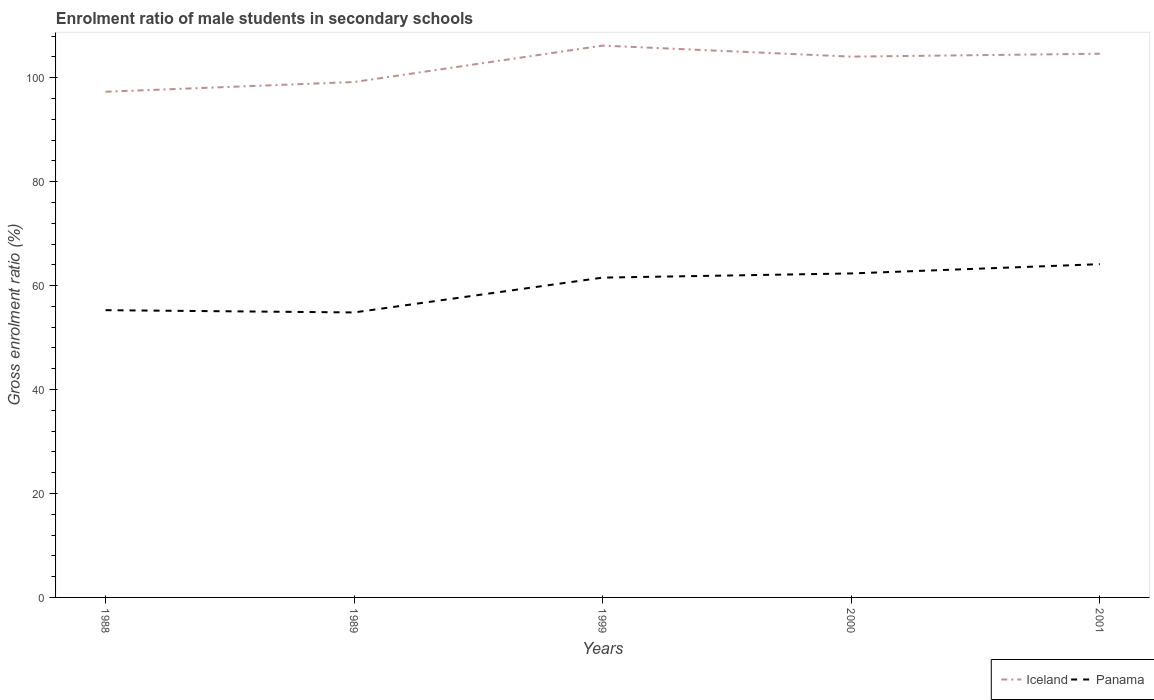Does the line corresponding to Iceland intersect with the line corresponding to Panama?
Ensure brevity in your answer.  No. Across all years, what is the maximum enrolment ratio of male students in secondary schools in Panama?
Your response must be concise. 54.83. In which year was the enrolment ratio of male students in secondary schools in Panama maximum?
Your answer should be very brief. 1989. What is the total enrolment ratio of male students in secondary schools in Iceland in the graph?
Provide a succinct answer. 2.12. What is the difference between the highest and the second highest enrolment ratio of male students in secondary schools in Iceland?
Offer a terse response. 8.88. Is the enrolment ratio of male students in secondary schools in Iceland strictly greater than the enrolment ratio of male students in secondary schools in Panama over the years?
Make the answer very short. No. How many years are there in the graph?
Keep it short and to the point. 5. Does the graph contain any zero values?
Your response must be concise. No. What is the title of the graph?
Offer a terse response. Enrolment ratio of male students in secondary schools. Does "Caribbean small states" appear as one of the legend labels in the graph?
Give a very brief answer. No. What is the label or title of the X-axis?
Keep it short and to the point. Years. What is the Gross enrolment ratio (%) in Iceland in 1988?
Make the answer very short. 97.3. What is the Gross enrolment ratio (%) of Panama in 1988?
Keep it short and to the point. 55.27. What is the Gross enrolment ratio (%) in Iceland in 1989?
Your answer should be compact. 99.17. What is the Gross enrolment ratio (%) of Panama in 1989?
Your answer should be compact. 54.83. What is the Gross enrolment ratio (%) of Iceland in 1999?
Provide a succinct answer. 106.18. What is the Gross enrolment ratio (%) of Panama in 1999?
Provide a succinct answer. 61.54. What is the Gross enrolment ratio (%) in Iceland in 2000?
Your response must be concise. 104.06. What is the Gross enrolment ratio (%) in Panama in 2000?
Ensure brevity in your answer.  62.34. What is the Gross enrolment ratio (%) of Iceland in 2001?
Ensure brevity in your answer.  104.61. What is the Gross enrolment ratio (%) in Panama in 2001?
Give a very brief answer. 64.13. Across all years, what is the maximum Gross enrolment ratio (%) of Iceland?
Keep it short and to the point. 106.18. Across all years, what is the maximum Gross enrolment ratio (%) of Panama?
Your answer should be very brief. 64.13. Across all years, what is the minimum Gross enrolment ratio (%) in Iceland?
Ensure brevity in your answer.  97.3. Across all years, what is the minimum Gross enrolment ratio (%) of Panama?
Provide a short and direct response. 54.83. What is the total Gross enrolment ratio (%) in Iceland in the graph?
Offer a terse response. 511.32. What is the total Gross enrolment ratio (%) in Panama in the graph?
Give a very brief answer. 298.11. What is the difference between the Gross enrolment ratio (%) in Iceland in 1988 and that in 1989?
Give a very brief answer. -1.87. What is the difference between the Gross enrolment ratio (%) in Panama in 1988 and that in 1989?
Your answer should be very brief. 0.44. What is the difference between the Gross enrolment ratio (%) of Iceland in 1988 and that in 1999?
Ensure brevity in your answer.  -8.88. What is the difference between the Gross enrolment ratio (%) in Panama in 1988 and that in 1999?
Your response must be concise. -6.26. What is the difference between the Gross enrolment ratio (%) of Iceland in 1988 and that in 2000?
Your response must be concise. -6.76. What is the difference between the Gross enrolment ratio (%) in Panama in 1988 and that in 2000?
Your response must be concise. -7.07. What is the difference between the Gross enrolment ratio (%) in Iceland in 1988 and that in 2001?
Provide a succinct answer. -7.31. What is the difference between the Gross enrolment ratio (%) in Panama in 1988 and that in 2001?
Provide a succinct answer. -8.85. What is the difference between the Gross enrolment ratio (%) of Iceland in 1989 and that in 1999?
Give a very brief answer. -7.01. What is the difference between the Gross enrolment ratio (%) of Panama in 1989 and that in 1999?
Provide a succinct answer. -6.7. What is the difference between the Gross enrolment ratio (%) in Iceland in 1989 and that in 2000?
Provide a short and direct response. -4.88. What is the difference between the Gross enrolment ratio (%) of Panama in 1989 and that in 2000?
Keep it short and to the point. -7.5. What is the difference between the Gross enrolment ratio (%) of Iceland in 1989 and that in 2001?
Ensure brevity in your answer.  -5.44. What is the difference between the Gross enrolment ratio (%) in Panama in 1989 and that in 2001?
Offer a terse response. -9.29. What is the difference between the Gross enrolment ratio (%) in Iceland in 1999 and that in 2000?
Offer a terse response. 2.12. What is the difference between the Gross enrolment ratio (%) of Panama in 1999 and that in 2000?
Your response must be concise. -0.8. What is the difference between the Gross enrolment ratio (%) of Iceland in 1999 and that in 2001?
Your answer should be compact. 1.57. What is the difference between the Gross enrolment ratio (%) of Panama in 1999 and that in 2001?
Provide a succinct answer. -2.59. What is the difference between the Gross enrolment ratio (%) of Iceland in 2000 and that in 2001?
Your response must be concise. -0.56. What is the difference between the Gross enrolment ratio (%) of Panama in 2000 and that in 2001?
Make the answer very short. -1.79. What is the difference between the Gross enrolment ratio (%) of Iceland in 1988 and the Gross enrolment ratio (%) of Panama in 1989?
Ensure brevity in your answer.  42.47. What is the difference between the Gross enrolment ratio (%) of Iceland in 1988 and the Gross enrolment ratio (%) of Panama in 1999?
Make the answer very short. 35.76. What is the difference between the Gross enrolment ratio (%) in Iceland in 1988 and the Gross enrolment ratio (%) in Panama in 2000?
Offer a very short reply. 34.96. What is the difference between the Gross enrolment ratio (%) in Iceland in 1988 and the Gross enrolment ratio (%) in Panama in 2001?
Your answer should be very brief. 33.17. What is the difference between the Gross enrolment ratio (%) of Iceland in 1989 and the Gross enrolment ratio (%) of Panama in 1999?
Provide a succinct answer. 37.64. What is the difference between the Gross enrolment ratio (%) of Iceland in 1989 and the Gross enrolment ratio (%) of Panama in 2000?
Make the answer very short. 36.83. What is the difference between the Gross enrolment ratio (%) of Iceland in 1989 and the Gross enrolment ratio (%) of Panama in 2001?
Your answer should be very brief. 35.05. What is the difference between the Gross enrolment ratio (%) in Iceland in 1999 and the Gross enrolment ratio (%) in Panama in 2000?
Provide a succinct answer. 43.84. What is the difference between the Gross enrolment ratio (%) of Iceland in 1999 and the Gross enrolment ratio (%) of Panama in 2001?
Keep it short and to the point. 42.05. What is the difference between the Gross enrolment ratio (%) in Iceland in 2000 and the Gross enrolment ratio (%) in Panama in 2001?
Give a very brief answer. 39.93. What is the average Gross enrolment ratio (%) of Iceland per year?
Provide a short and direct response. 102.26. What is the average Gross enrolment ratio (%) of Panama per year?
Offer a very short reply. 59.62. In the year 1988, what is the difference between the Gross enrolment ratio (%) of Iceland and Gross enrolment ratio (%) of Panama?
Offer a very short reply. 42.03. In the year 1989, what is the difference between the Gross enrolment ratio (%) of Iceland and Gross enrolment ratio (%) of Panama?
Your response must be concise. 44.34. In the year 1999, what is the difference between the Gross enrolment ratio (%) of Iceland and Gross enrolment ratio (%) of Panama?
Your answer should be very brief. 44.64. In the year 2000, what is the difference between the Gross enrolment ratio (%) of Iceland and Gross enrolment ratio (%) of Panama?
Keep it short and to the point. 41.72. In the year 2001, what is the difference between the Gross enrolment ratio (%) of Iceland and Gross enrolment ratio (%) of Panama?
Provide a succinct answer. 40.49. What is the ratio of the Gross enrolment ratio (%) of Iceland in 1988 to that in 1989?
Your answer should be compact. 0.98. What is the ratio of the Gross enrolment ratio (%) in Iceland in 1988 to that in 1999?
Your response must be concise. 0.92. What is the ratio of the Gross enrolment ratio (%) in Panama in 1988 to that in 1999?
Make the answer very short. 0.9. What is the ratio of the Gross enrolment ratio (%) of Iceland in 1988 to that in 2000?
Your answer should be compact. 0.94. What is the ratio of the Gross enrolment ratio (%) of Panama in 1988 to that in 2000?
Give a very brief answer. 0.89. What is the ratio of the Gross enrolment ratio (%) in Iceland in 1988 to that in 2001?
Make the answer very short. 0.93. What is the ratio of the Gross enrolment ratio (%) of Panama in 1988 to that in 2001?
Make the answer very short. 0.86. What is the ratio of the Gross enrolment ratio (%) of Iceland in 1989 to that in 1999?
Ensure brevity in your answer.  0.93. What is the ratio of the Gross enrolment ratio (%) in Panama in 1989 to that in 1999?
Ensure brevity in your answer.  0.89. What is the ratio of the Gross enrolment ratio (%) in Iceland in 1989 to that in 2000?
Your answer should be compact. 0.95. What is the ratio of the Gross enrolment ratio (%) of Panama in 1989 to that in 2000?
Your answer should be compact. 0.88. What is the ratio of the Gross enrolment ratio (%) in Iceland in 1989 to that in 2001?
Make the answer very short. 0.95. What is the ratio of the Gross enrolment ratio (%) of Panama in 1989 to that in 2001?
Make the answer very short. 0.86. What is the ratio of the Gross enrolment ratio (%) of Iceland in 1999 to that in 2000?
Your response must be concise. 1.02. What is the ratio of the Gross enrolment ratio (%) in Panama in 1999 to that in 2000?
Offer a terse response. 0.99. What is the ratio of the Gross enrolment ratio (%) of Iceland in 1999 to that in 2001?
Your answer should be very brief. 1.01. What is the ratio of the Gross enrolment ratio (%) of Panama in 1999 to that in 2001?
Give a very brief answer. 0.96. What is the ratio of the Gross enrolment ratio (%) of Iceland in 2000 to that in 2001?
Provide a succinct answer. 0.99. What is the ratio of the Gross enrolment ratio (%) in Panama in 2000 to that in 2001?
Your answer should be compact. 0.97. What is the difference between the highest and the second highest Gross enrolment ratio (%) in Iceland?
Provide a short and direct response. 1.57. What is the difference between the highest and the second highest Gross enrolment ratio (%) of Panama?
Keep it short and to the point. 1.79. What is the difference between the highest and the lowest Gross enrolment ratio (%) in Iceland?
Keep it short and to the point. 8.88. What is the difference between the highest and the lowest Gross enrolment ratio (%) in Panama?
Your response must be concise. 9.29. 